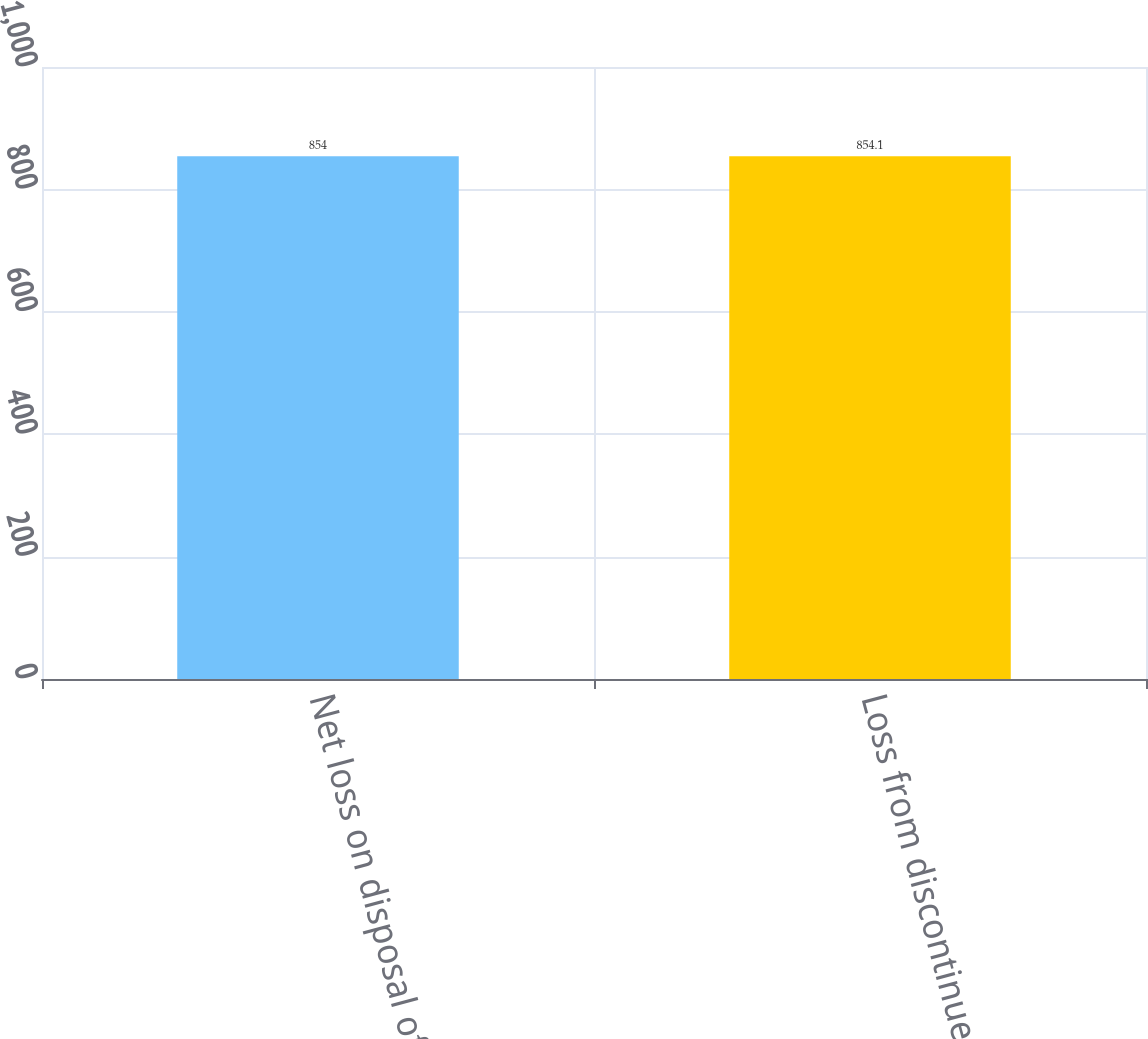Convert chart to OTSL. <chart><loc_0><loc_0><loc_500><loc_500><bar_chart><fcel>Net loss on disposal of<fcel>Loss from discontinued<nl><fcel>854<fcel>854.1<nl></chart> 